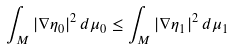<formula> <loc_0><loc_0><loc_500><loc_500>\int _ { M } | \nabla \eta _ { 0 } | ^ { 2 } \, d \mu _ { 0 } \leq \int _ { M } | \nabla \eta _ { 1 } | ^ { 2 } \, d \mu _ { 1 }</formula> 